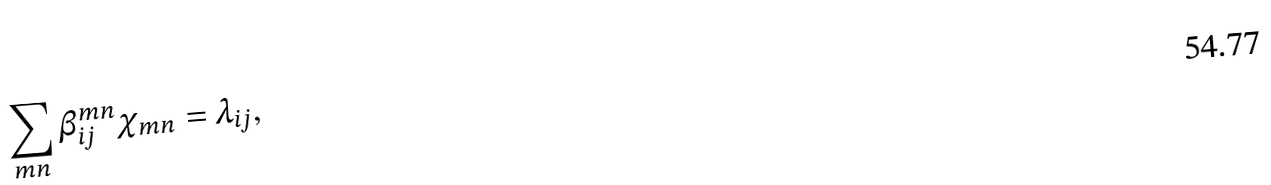Convert formula to latex. <formula><loc_0><loc_0><loc_500><loc_500>\sum _ { m n } \beta ^ { m n } _ { i j } \chi _ { m n } = \lambda _ { i j } ,</formula> 